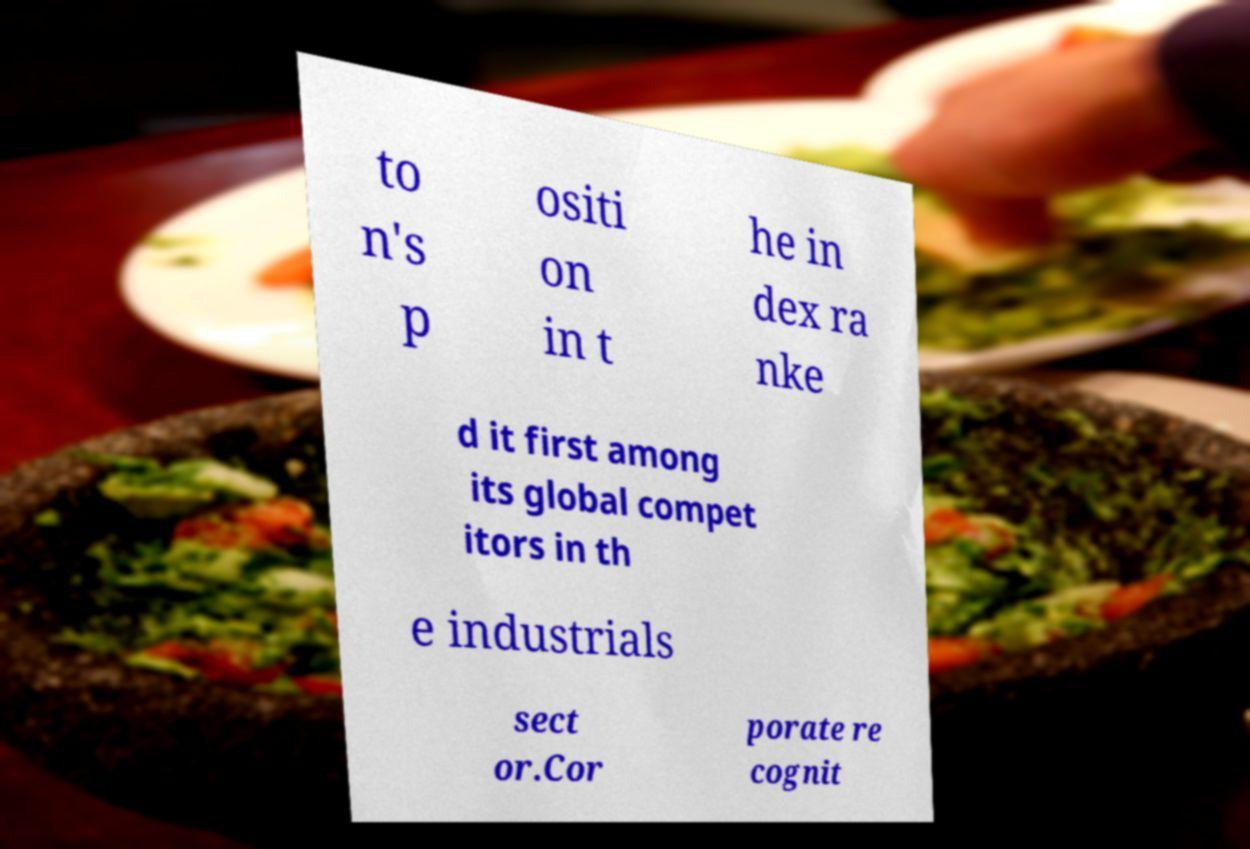There's text embedded in this image that I need extracted. Can you transcribe it verbatim? to n's p ositi on in t he in dex ra nke d it first among its global compet itors in th e industrials sect or.Cor porate re cognit 